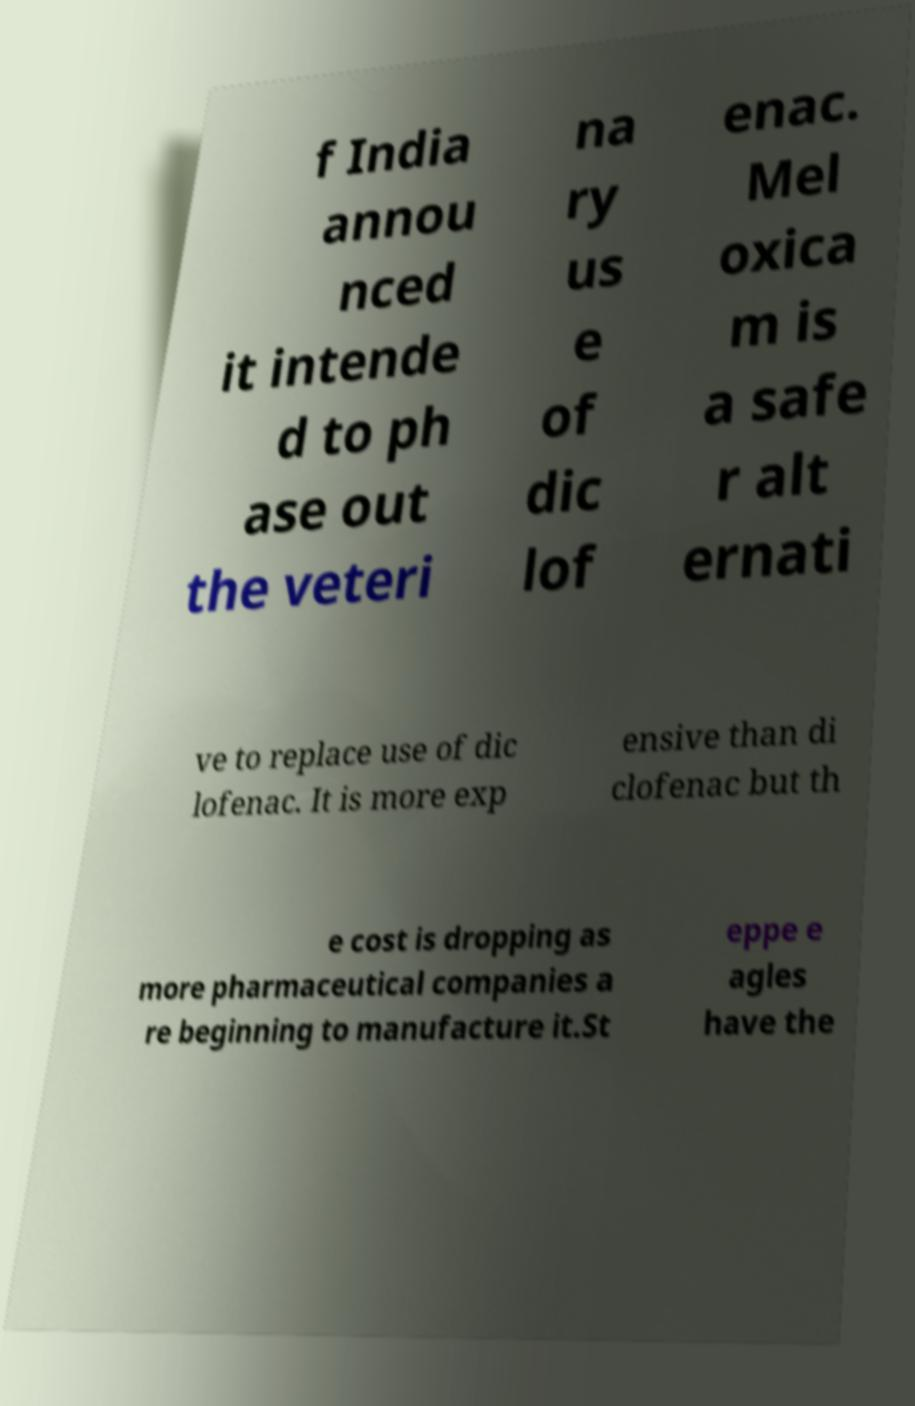Can you accurately transcribe the text from the provided image for me? f India annou nced it intende d to ph ase out the veteri na ry us e of dic lof enac. Mel oxica m is a safe r alt ernati ve to replace use of dic lofenac. It is more exp ensive than di clofenac but th e cost is dropping as more pharmaceutical companies a re beginning to manufacture it.St eppe e agles have the 